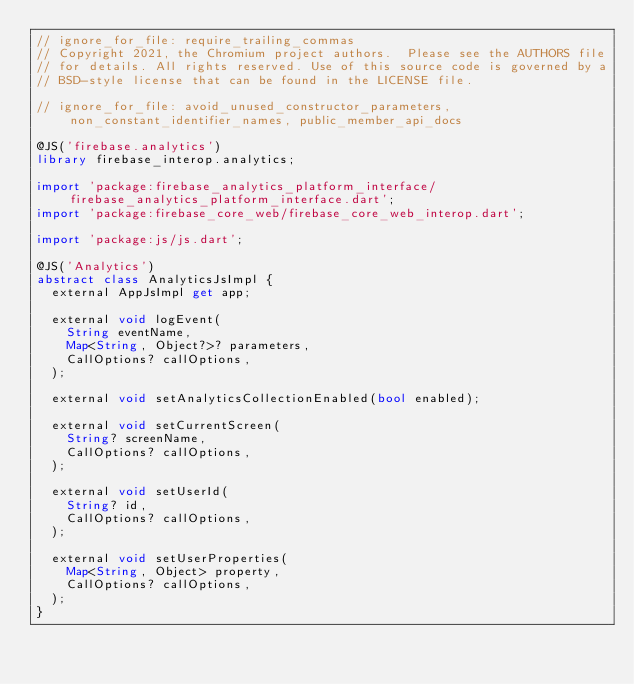<code> <loc_0><loc_0><loc_500><loc_500><_Dart_>// ignore_for_file: require_trailing_commas
// Copyright 2021, the Chromium project authors.  Please see the AUTHORS file
// for details. All rights reserved. Use of this source code is governed by a
// BSD-style license that can be found in the LICENSE file.

// ignore_for_file: avoid_unused_constructor_parameters, non_constant_identifier_names, public_member_api_docs

@JS('firebase.analytics')
library firebase_interop.analytics;

import 'package:firebase_analytics_platform_interface/firebase_analytics_platform_interface.dart';
import 'package:firebase_core_web/firebase_core_web_interop.dart';

import 'package:js/js.dart';

@JS('Analytics')
abstract class AnalyticsJsImpl {
  external AppJsImpl get app;

  external void logEvent(
    String eventName,
    Map<String, Object?>? parameters,
    CallOptions? callOptions,
  );

  external void setAnalyticsCollectionEnabled(bool enabled);

  external void setCurrentScreen(
    String? screenName,
    CallOptions? callOptions,
  );

  external void setUserId(
    String? id,
    CallOptions? callOptions,
  );

  external void setUserProperties(
    Map<String, Object> property,
    CallOptions? callOptions,
  );
}
</code> 